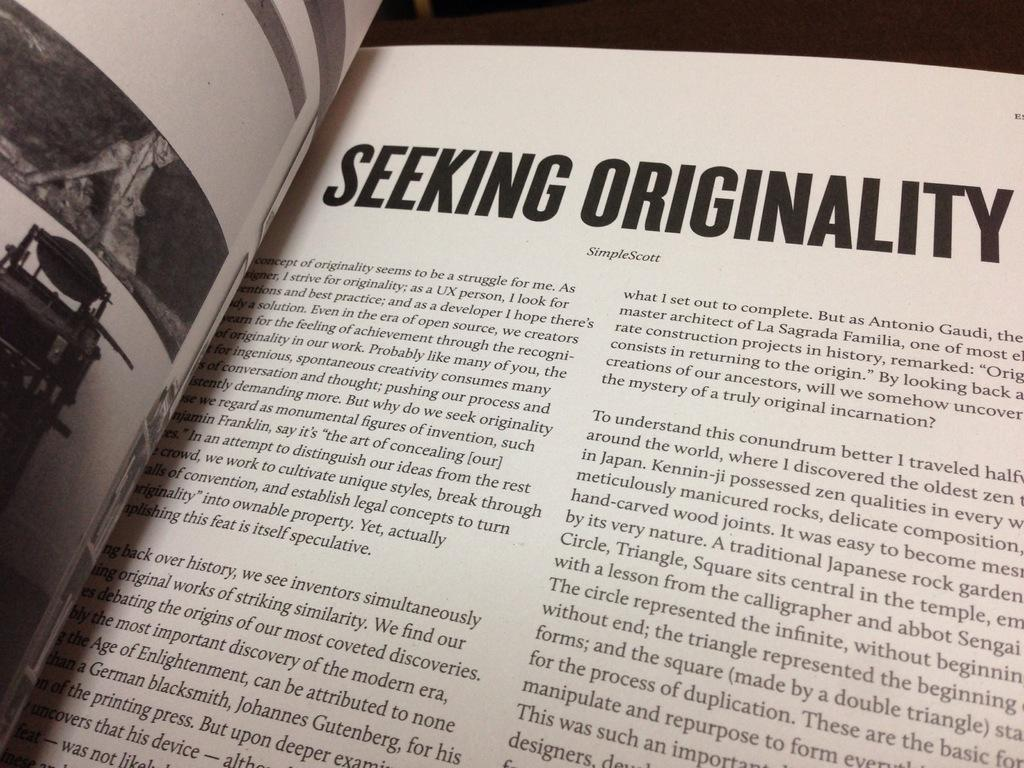<image>
Describe the image concisely. The book is opened to the seeking originalty page 